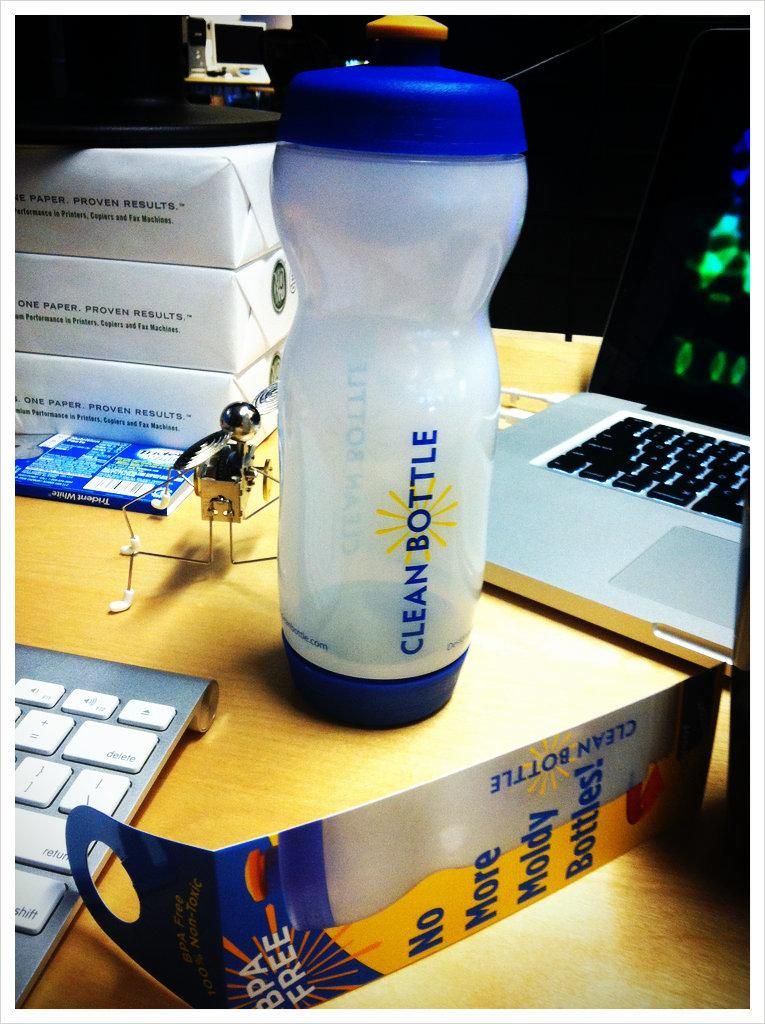<image>
Share a concise interpretation of the image provided. a water bottle on a desk labelled clean bottle 